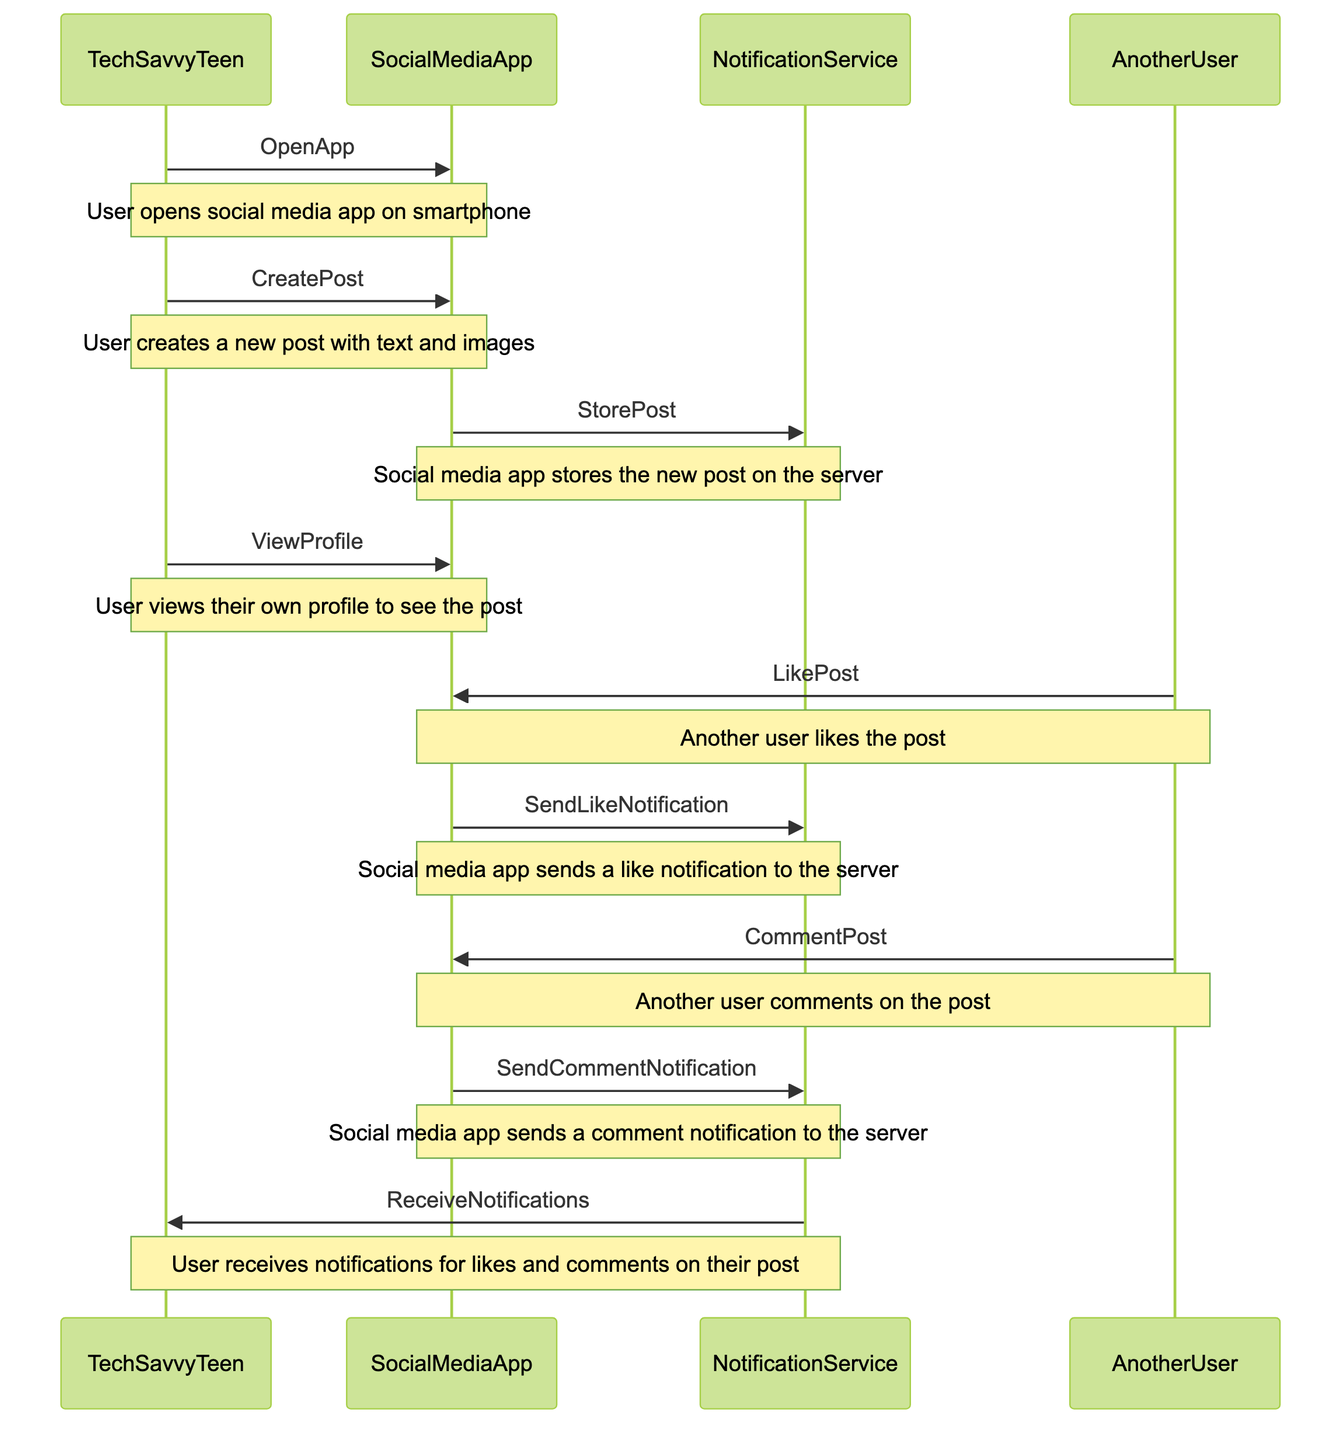What action does TechSavvyTeen perform first? The first action in the diagram is "OpenApp," where TechSavvyTeen opens the social media app on their smartphone. This action initiates the interaction with the SocialMediaApp.
Answer: OpenApp How many users are involved in the interactions? The interactions involve two users: TechSavvyTeen and AnotherUser. TechSavvyTeen creates a post, and AnotherUser likes and comments on the post, contributing to the interactions represented in the diagram.
Answer: Two What does SocialMediaApp do after the post is created? After the post is created, SocialMediaApp performs the action "StorePost," which involves storing the new post on the server within the NotificationService. This is a critical step in the workflow for post creation.
Answer: StorePost Which service sends notifications to TechSavvyTeen? The notifications are sent to TechSavvyTeen by the NotificationService, which receives the data from SocialMediaApp after users interact with the post. This service acts as the intermediary that delivers notifications about likes and comments.
Answer: NotificationService What is the last action performed in the workflow? The last action shown in the sequence diagram is "ReceiveNotifications," where TechSavvyTeen receives notifications for likes and comments on their post. This concludes the interaction workflow displayed in the diagram.
Answer: ReceiveNotifications What action does AnotherUser perform after liking the post? After liking the post, AnotherUser performs the action "CommentPost." This action involves another form of interaction with the post, demonstrating engagement from others in the social media environment.
Answer: CommentPost How does SocialMediaApp respond to the LikePost action? SocialMediaApp responds to the LikePost action by sending a notification to the NotificationService via the action "SendLikeNotification." This allows the notification of the like to be processed and eventually delivered to TechSavvyTeen.
Answer: SendLikeNotification Which two actions does NotificationService perform in the workflow? NotificationService performs two actions: "SendLikeNotification" and "SendCommentNotification." Both actions are crucial as they facilitate the communication of user interactions (likes and comments) back to TechSavvyTeen.
Answer: SendLikeNotification, SendCommentNotification 